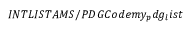Convert formula to latex. <formula><loc_0><loc_0><loc_500><loc_500>I N T L I S T A M S / P D G C o d e m y _ { p } d g _ { l } i s t</formula> 